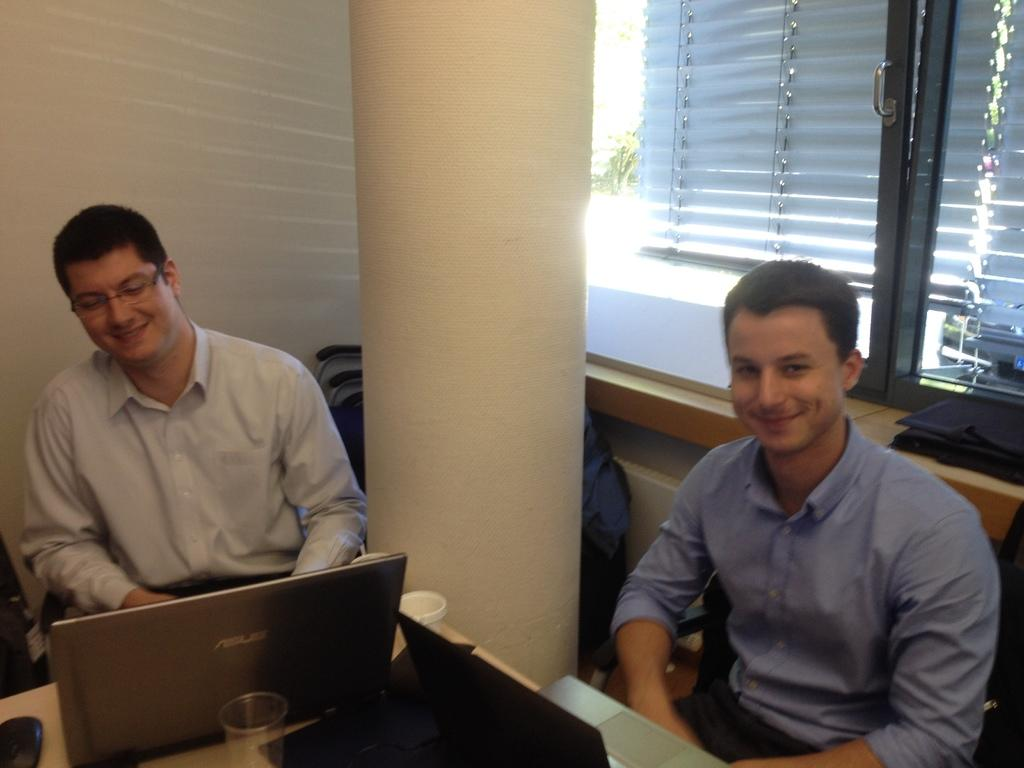How many people are in the image? There are two men in the image. What are the men doing in the image? The men are sitting. What expressions do the men have on their faces? The men have smiles on their faces. Can you describe any accessories worn by one of the men? One of the men is wearing glasses (specs). What electronic device is present in the image? There is a laptop in the image. What other objects can be seen in the image? There is a cup and a mouse (likely a computer mouse) in the image. What type of memory is being shared among the group in the image? There is no group present in the image, only two men. Additionally, there is no mention of any shared memory. 